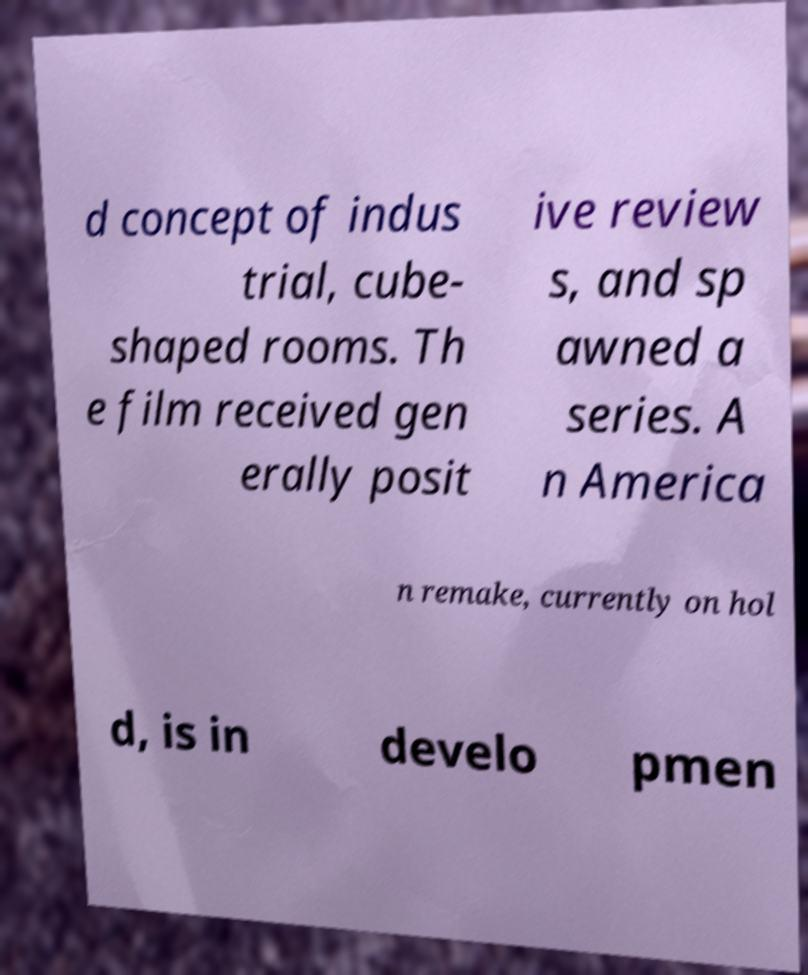Could you extract and type out the text from this image? d concept of indus trial, cube- shaped rooms. Th e film received gen erally posit ive review s, and sp awned a series. A n America n remake, currently on hol d, is in develo pmen 